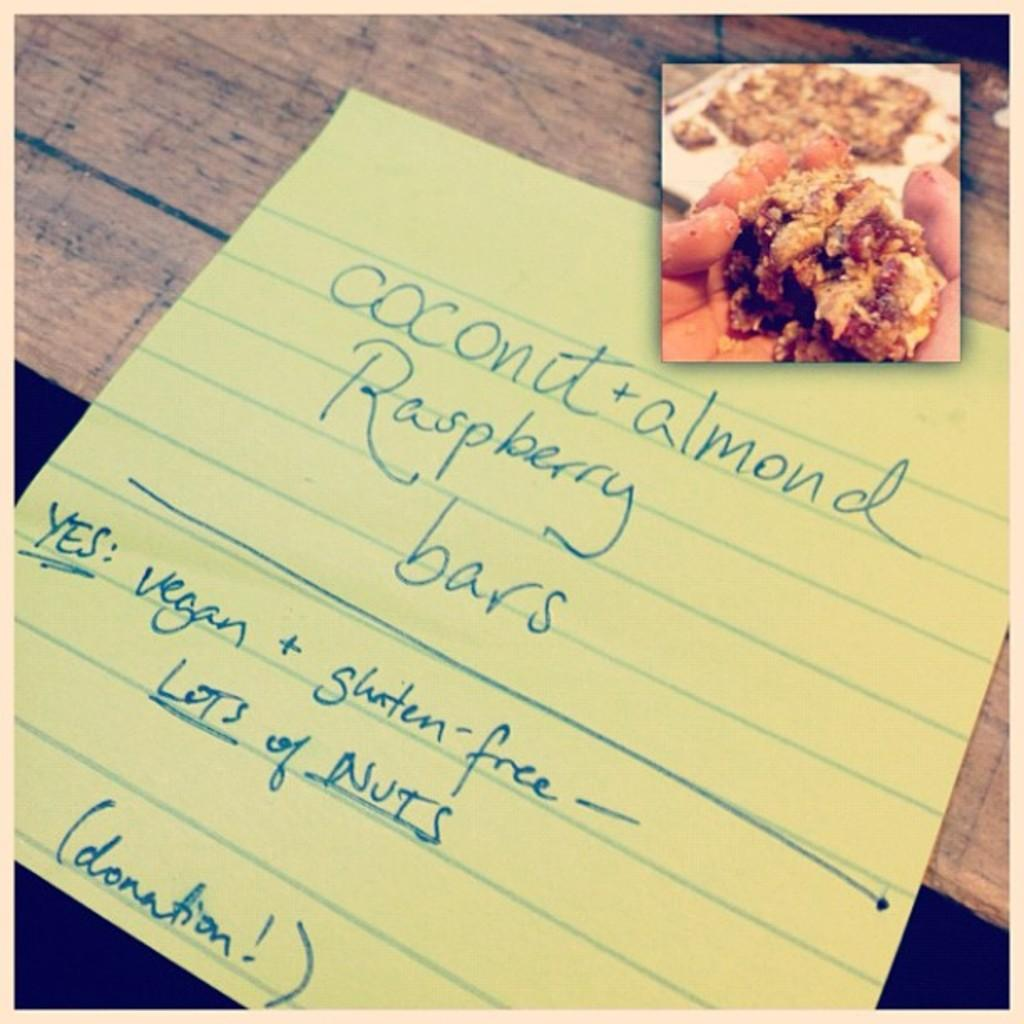<image>
Present a compact description of the photo's key features. The yellow paper has Coconut written on it 